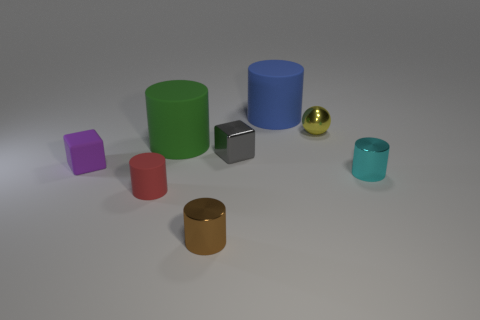What number of blocks have the same size as the metallic ball?
Provide a succinct answer. 2. How many small cyan rubber cylinders are there?
Give a very brief answer. 0. Is the tiny brown thing made of the same material as the small block that is left of the big green rubber thing?
Your response must be concise. No. How many purple things are rubber things or small matte cubes?
Provide a short and direct response. 1. There is a cyan cylinder that is made of the same material as the brown cylinder; what size is it?
Your response must be concise. Small. What number of large matte things are the same shape as the brown shiny object?
Offer a very short reply. 2. Is the number of small cyan shiny objects to the left of the purple cube greater than the number of green objects in front of the large blue rubber cylinder?
Ensure brevity in your answer.  No. There is a purple object that is the same size as the yellow metal object; what is it made of?
Make the answer very short. Rubber. What number of objects are either gray matte objects or big cylinders behind the yellow ball?
Provide a short and direct response. 1. Do the ball and the object behind the small yellow sphere have the same size?
Your answer should be very brief. No. 